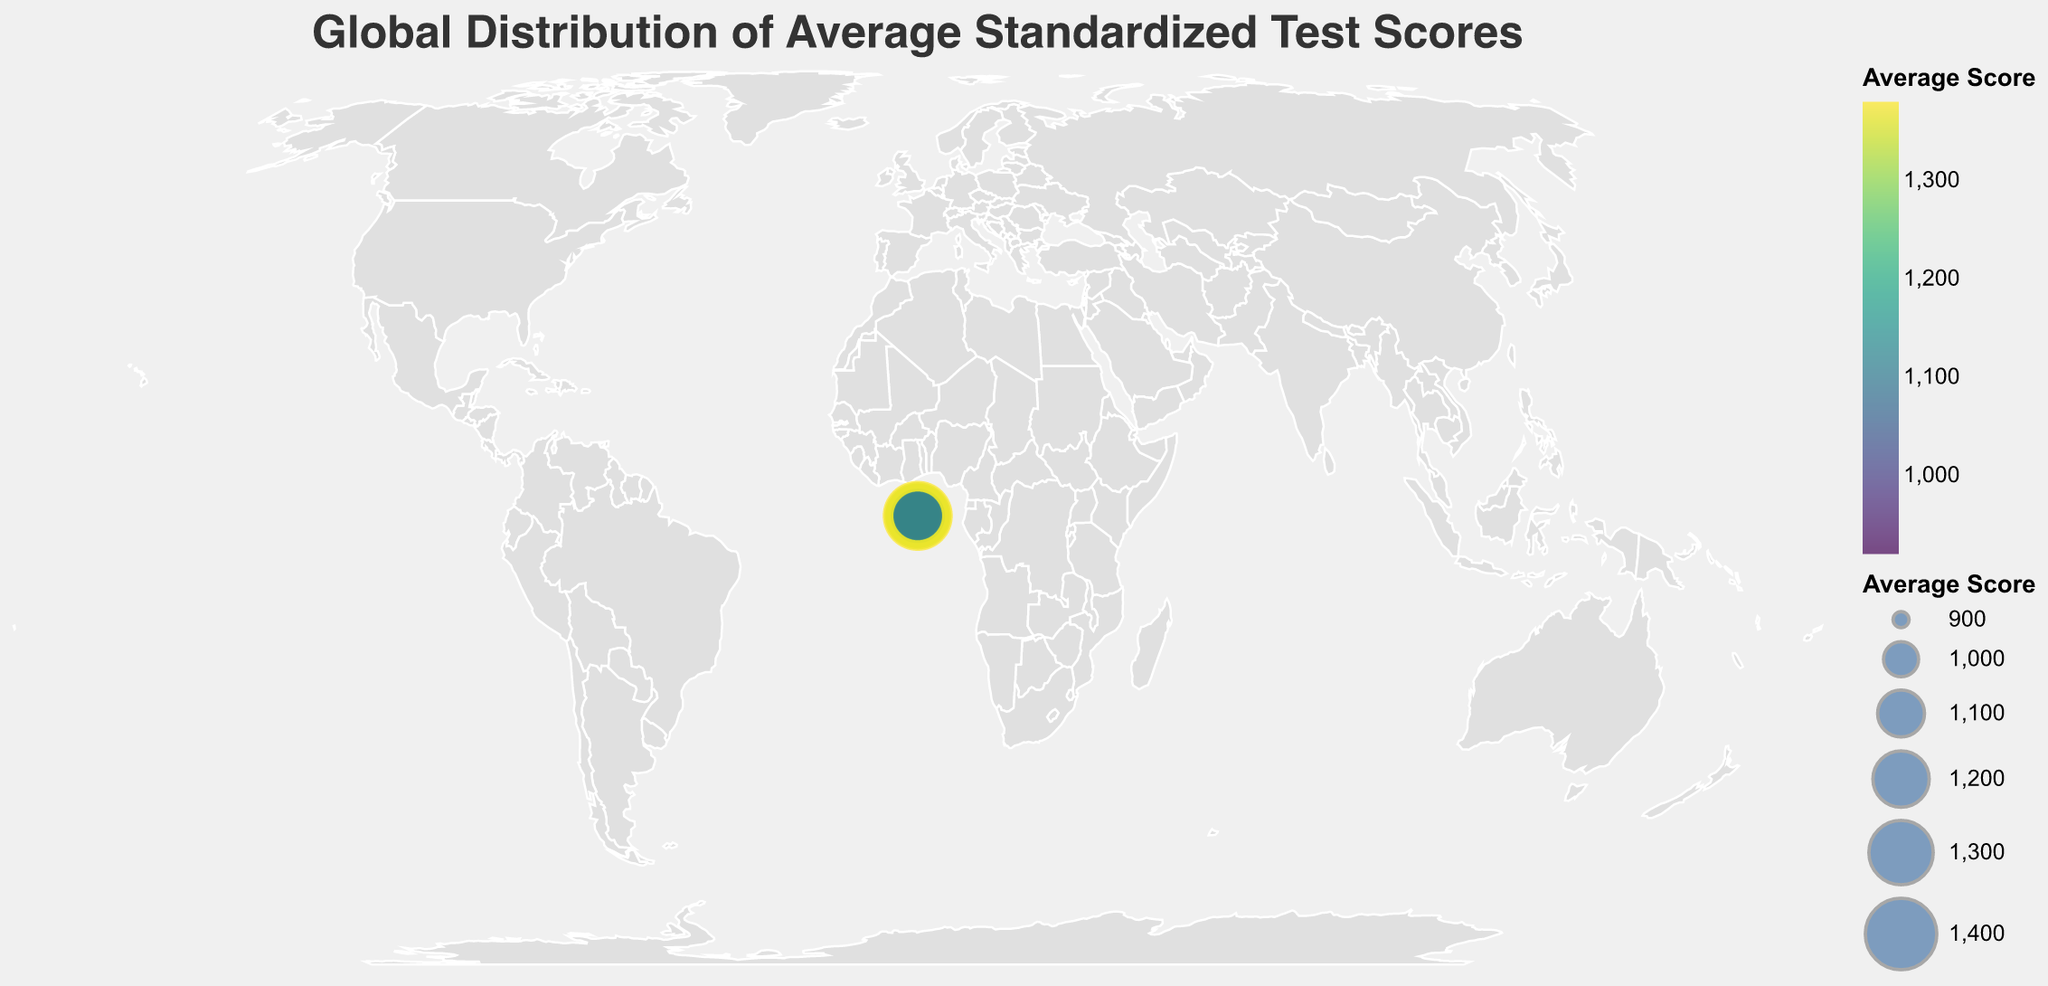Which country has the highest average standardized test score? By examining the size and color of the markers on the visualized map, it is clear that Singapore has the highest value at 1380.
Answer: Singapore What's the title of the figure? The text at the top of the figure clearly states "Global Distribution of Average Standardized Test Scores".
Answer: Global Distribution of Average Standardized Test Scores How many countries have average standardized test scores greater than 1100? From the data, the countries with scores above 1100 are China, Japan, South Korea, Singapore, Finland, and Norway. This makes a total of 6 countries.
Answer: 6 Which country in North America has the highest average standardized test score? By looking at the corresponding geographical markers in North America, Canada has the highest score at 1040, which is higher than the United States and Mexico.
Answer: Canada What's the difference in average standardized test scores between the highest and lowest scoring countries? Singapore has the highest score at 1380, and Brazil has the lowest at 920. The difference is 1380 - 920 = 460.
Answer: 460 Which continents have countries represented with an average standardized test score below 1000? The countries with scores below 1000 are India (Asia), Brazil (South America), and Mexico (North America).
Answer: Asia, South America, North America What is the average standardized test score of European countries in the dataset? The European countries listed are Germany (1100), United Kingdom (1050), France (1080), Russia (1060), Italy (990), Spain (1010), Netherlands (1070), Sweden (1090), and Finland (1120). Sum: 8480, Number of countries: 9. Average: 8480/9 = 942.22
Answer: 942.22 How does the average standardized test score of South Korea compare to Japan? South Korea has an average score of 1340, which is 160 points higher than Japan's 1180.
Answer: South Korea's score is higher by 160 points Which country has an average standardized test score closest to 1000? Italy has an average standardized test score of 990, which is the closest to 1000 on the list.
Answer: Italy 